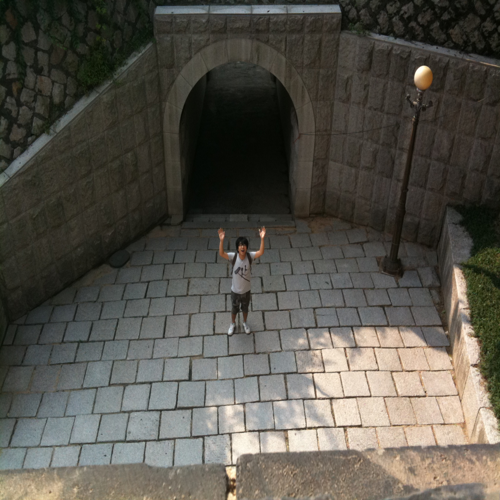What time of day does this photo seem to be taken? Given the length and the angle of the shadows, it seems to be taken in the early morning or late afternoon when the sun is lower in the sky. 